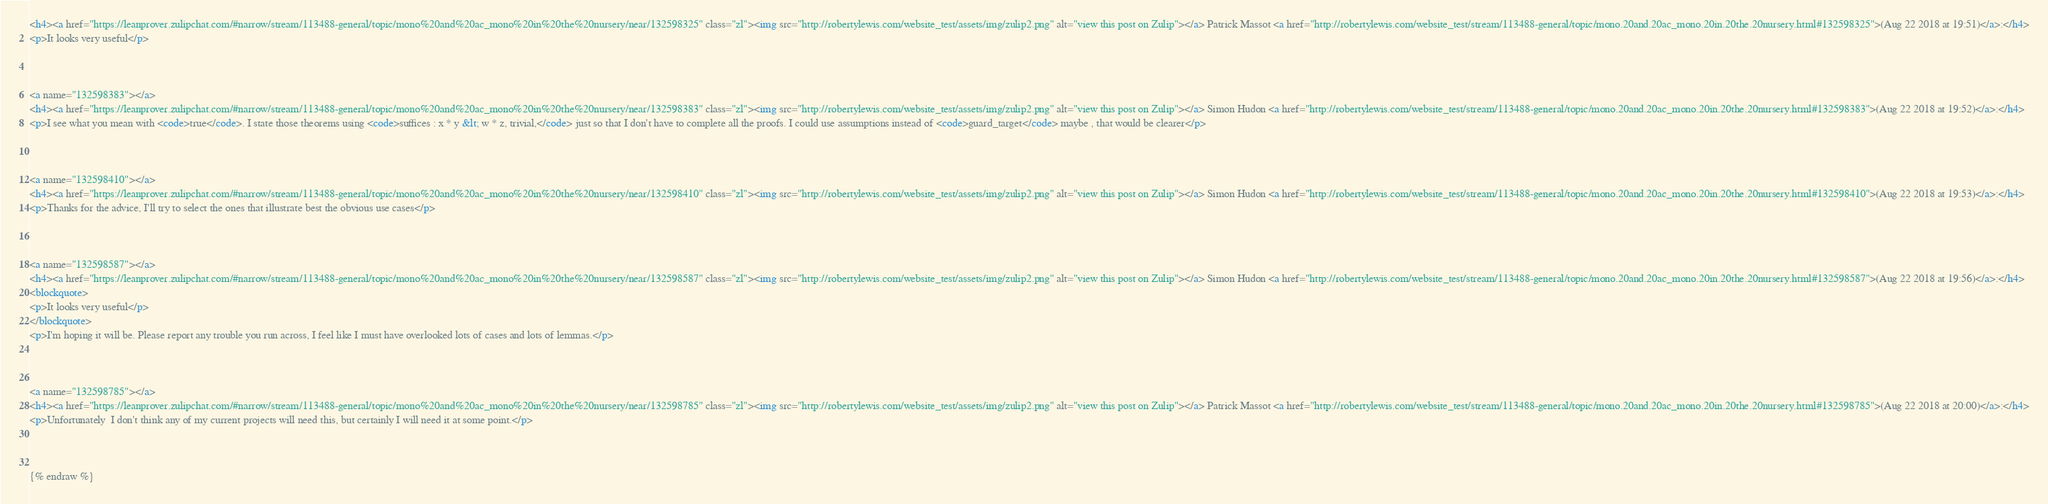<code> <loc_0><loc_0><loc_500><loc_500><_HTML_><h4><a href="https://leanprover.zulipchat.com/#narrow/stream/113488-general/topic/mono%20and%20ac_mono%20in%20the%20nursery/near/132598325" class="zl"><img src="http://robertylewis.com/website_test/assets/img/zulip2.png" alt="view this post on Zulip"></a> Patrick Massot <a href="http://robertylewis.com/website_test/stream/113488-general/topic/mono.20and.20ac_mono.20in.20the.20nursery.html#132598325">(Aug 22 2018 at 19:51)</a>:</h4>
<p>It looks very useful</p>



<a name="132598383"></a>
<h4><a href="https://leanprover.zulipchat.com/#narrow/stream/113488-general/topic/mono%20and%20ac_mono%20in%20the%20nursery/near/132598383" class="zl"><img src="http://robertylewis.com/website_test/assets/img/zulip2.png" alt="view this post on Zulip"></a> Simon Hudon <a href="http://robertylewis.com/website_test/stream/113488-general/topic/mono.20and.20ac_mono.20in.20the.20nursery.html#132598383">(Aug 22 2018 at 19:52)</a>:</h4>
<p>I see what you mean with <code>true</code>. I state those theorems using <code>suffices : x * y &lt; w * z, trivial,</code> just so that I don't have to complete all the proofs. I could use assumptions instead of <code>guard_target</code> maybe , that would be clearer</p>



<a name="132598410"></a>
<h4><a href="https://leanprover.zulipchat.com/#narrow/stream/113488-general/topic/mono%20and%20ac_mono%20in%20the%20nursery/near/132598410" class="zl"><img src="http://robertylewis.com/website_test/assets/img/zulip2.png" alt="view this post on Zulip"></a> Simon Hudon <a href="http://robertylewis.com/website_test/stream/113488-general/topic/mono.20and.20ac_mono.20in.20the.20nursery.html#132598410">(Aug 22 2018 at 19:53)</a>:</h4>
<p>Thanks for the advice, I'll try to select the ones that illustrate best the obvious use cases</p>



<a name="132598587"></a>
<h4><a href="https://leanprover.zulipchat.com/#narrow/stream/113488-general/topic/mono%20and%20ac_mono%20in%20the%20nursery/near/132598587" class="zl"><img src="http://robertylewis.com/website_test/assets/img/zulip2.png" alt="view this post on Zulip"></a> Simon Hudon <a href="http://robertylewis.com/website_test/stream/113488-general/topic/mono.20and.20ac_mono.20in.20the.20nursery.html#132598587">(Aug 22 2018 at 19:56)</a>:</h4>
<blockquote>
<p>It looks very useful</p>
</blockquote>
<p>I'm hoping it will be. Please report any trouble you run across, I feel like I must have overlooked lots of cases and lots of lemmas.</p>



<a name="132598785"></a>
<h4><a href="https://leanprover.zulipchat.com/#narrow/stream/113488-general/topic/mono%20and%20ac_mono%20in%20the%20nursery/near/132598785" class="zl"><img src="http://robertylewis.com/website_test/assets/img/zulip2.png" alt="view this post on Zulip"></a> Patrick Massot <a href="http://robertylewis.com/website_test/stream/113488-general/topic/mono.20and.20ac_mono.20in.20the.20nursery.html#132598785">(Aug 22 2018 at 20:00)</a>:</h4>
<p>Unfortunately  I don't think any of my current projects will need this, but certainly I will need it at some point.</p>



{% endraw %}
</code> 